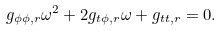<formula> <loc_0><loc_0><loc_500><loc_500>g _ { \phi \phi , r } \omega ^ { 2 } + 2 g _ { t \phi , r } \omega + g _ { t t , r } = 0 .</formula> 